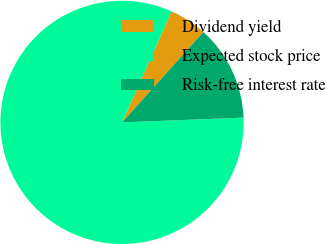Convert chart. <chart><loc_0><loc_0><loc_500><loc_500><pie_chart><fcel>Dividend yield<fcel>Expected stock price<fcel>Risk-free interest rate<nl><fcel>4.98%<fcel>82.31%<fcel>12.71%<nl></chart> 